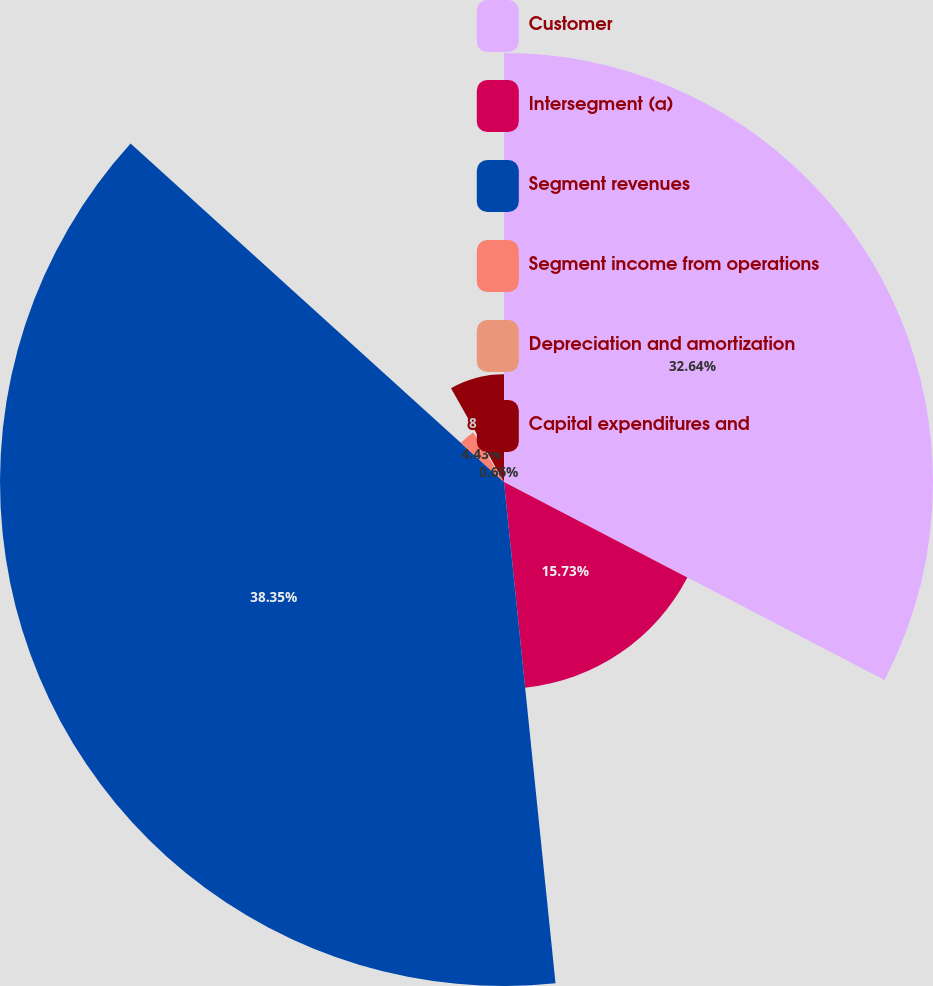Convert chart to OTSL. <chart><loc_0><loc_0><loc_500><loc_500><pie_chart><fcel>Customer<fcel>Intersegment (a)<fcel>Segment revenues<fcel>Segment income from operations<fcel>Depreciation and amortization<fcel>Capital expenditures and<nl><fcel>32.64%<fcel>15.73%<fcel>38.35%<fcel>4.43%<fcel>0.66%<fcel>8.19%<nl></chart> 